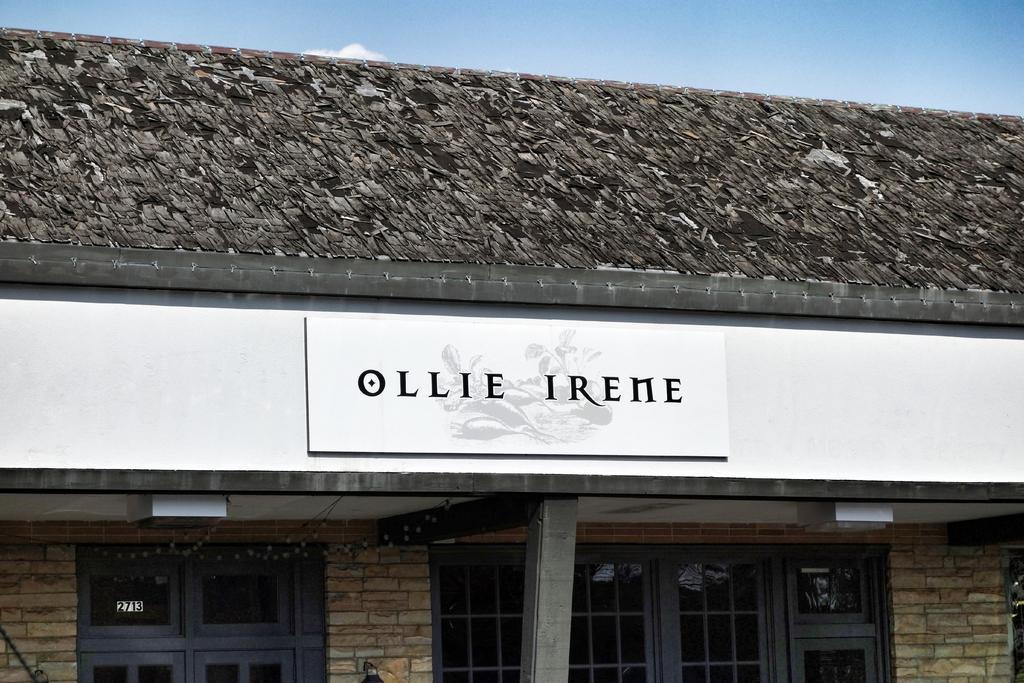Describe this image in one or two sentences. In the image we can see there is a building and there are windows on the building. There is a banner on the building. 